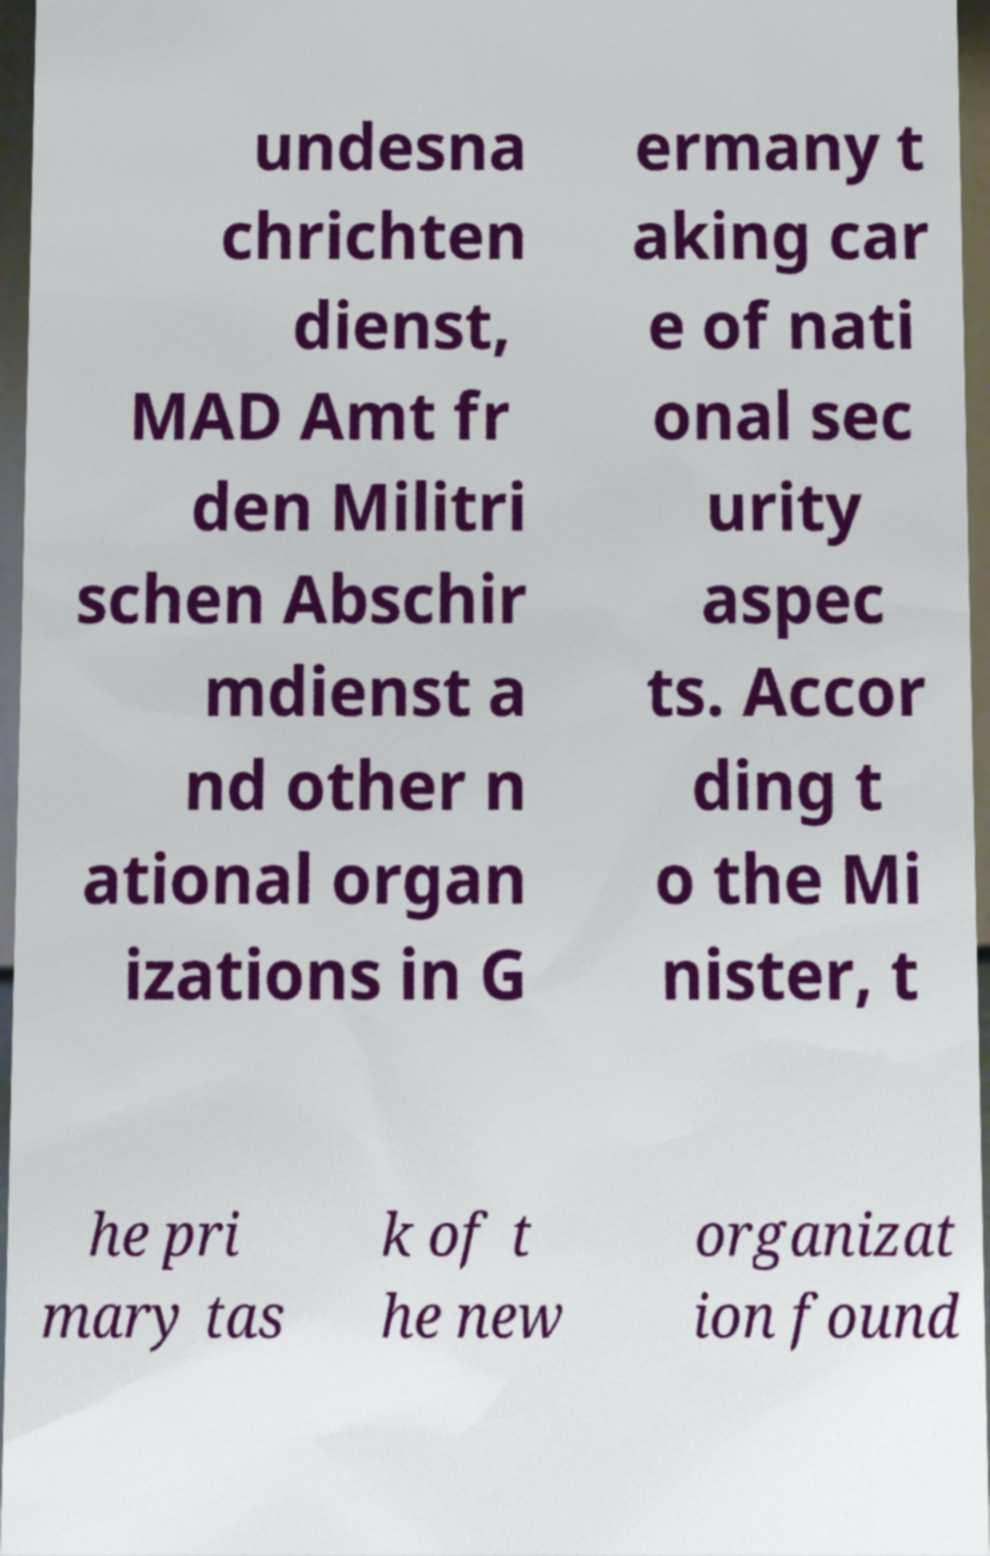Please identify and transcribe the text found in this image. undesna chrichten dienst, MAD Amt fr den Militri schen Abschir mdienst a nd other n ational organ izations in G ermany t aking car e of nati onal sec urity aspec ts. Accor ding t o the Mi nister, t he pri mary tas k of t he new organizat ion found 